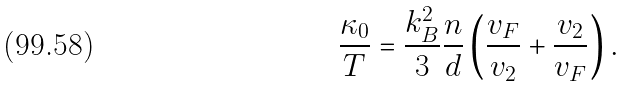<formula> <loc_0><loc_0><loc_500><loc_500>\frac { \kappa _ { 0 } } { T } = \frac { k _ { B } ^ { 2 } } { 3 } \frac { n } { d } \left ( \frac { v _ { F } } { v _ { 2 } } + \frac { v _ { 2 } } { v _ { F } } \right ) .</formula> 